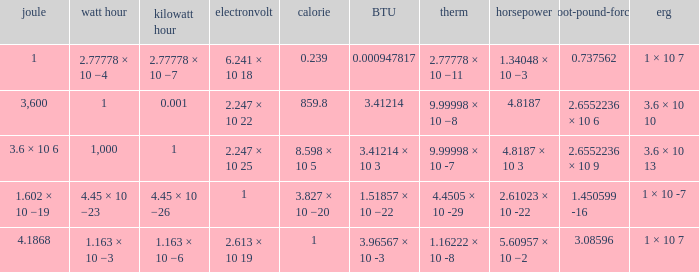Parse the table in full. {'header': ['joule', 'watt hour', 'kilowatt hour', 'electronvolt', 'calorie', 'BTU', 'therm', 'horsepower', 'foot-pound-force', 'erg'], 'rows': [['1', '2.77778 × 10 −4', '2.77778 × 10 −7', '6.241 × 10 18', '0.239', '0.000947817', '2.77778 × 10 −11', '1.34048 × 10 −3', '0.737562', '1 × 10 7'], ['3,600', '1', '0.001', '2.247 × 10 22', '859.8', '3.41214', '9.99998 × 10 −8', '4.8187', '2.6552236 × 10 6', '3.6 × 10 10'], ['3.6 × 10 6', '1,000', '1', '2.247 × 10 25', '8.598 × 10 5', '3.41214 × 10 3', '9.99998 × 10 -7', '4.8187 × 10 3', '2.6552236 × 10 9', '3.6 × 10 13'], ['1.602 × 10 −19', '4.45 × 10 −23', '4.45 × 10 −26', '1', '3.827 × 10 −20', '1.51857 × 10 −22', '4.4505 × 10 -29', '2.61023 × 10 -22', '1.450599 -16', '1 × 10 -7'], ['4.1868', '1.163 × 10 −3', '1.163 × 10 −6', '2.613 × 10 19', '1', '3.96567 × 10 -3', '1.16222 × 10 -8', '5.60957 × 10 −2', '3.08596', '1 × 10 7']]} How many calories is 1 watt hour? 859.8. 